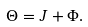Convert formula to latex. <formula><loc_0><loc_0><loc_500><loc_500>\Theta = J + \Phi .</formula> 